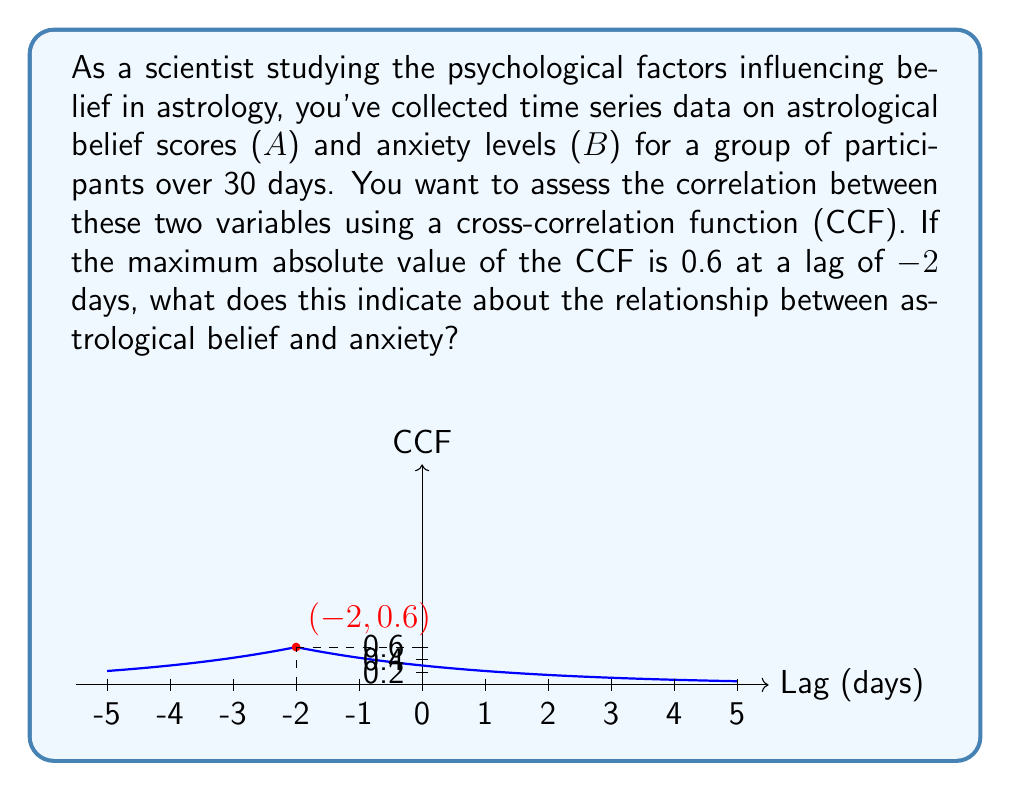Could you help me with this problem? To interpret the cross-correlation function (CCF) results, we need to follow these steps:

1) Understand the CCF: The CCF measures the correlation between two time series at different time lags. It ranges from -1 to 1, where:
   - 1 indicates perfect positive correlation
   - -1 indicates perfect negative correlation
   - 0 indicates no correlation

2) Interpret the CCF value:
   The maximum absolute CCF value is 0.6, which indicates a moderate positive correlation between astrological belief and anxiety.

3) Interpret the lag:
   The lag of -2 days means that changes in anxiety (B) precede changes in astrological belief (A) by 2 days.

4) Direction of the relationship:
   Since the CCF is positive (0.6), it suggests that as anxiety increases, astrological belief tends to increase 2 days later.

5) Causality:
   While the CCF suggests a temporal relationship, it doesn't prove causality. Other factors could influence both variables.

6) Practical interpretation:
   This result suggests that periods of higher anxiety might lead to increased belief in astrology two days later. This could be due to people seeking comfort or explanations in astrological beliefs when feeling anxious.

The negative lag (-2) is crucial here. In CCF notation, a negative lag means that changes in the second variable (B, anxiety) precede changes in the first variable (A, astrological belief).
Answer: Moderate positive correlation; anxiety changes precede astrological belief changes by 2 days. 